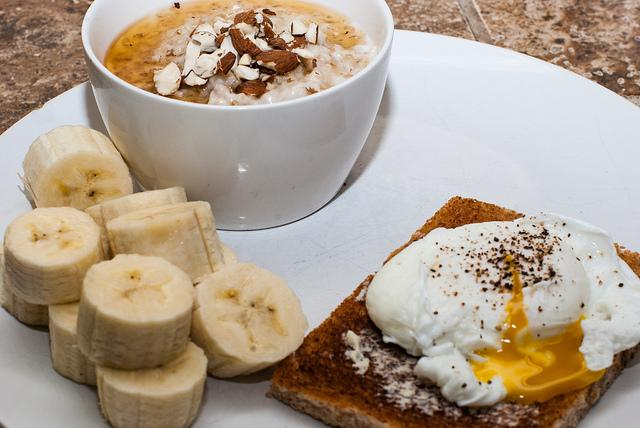What is this style of egg called? Please explain your reasoning. poached. The eggs are poached. 